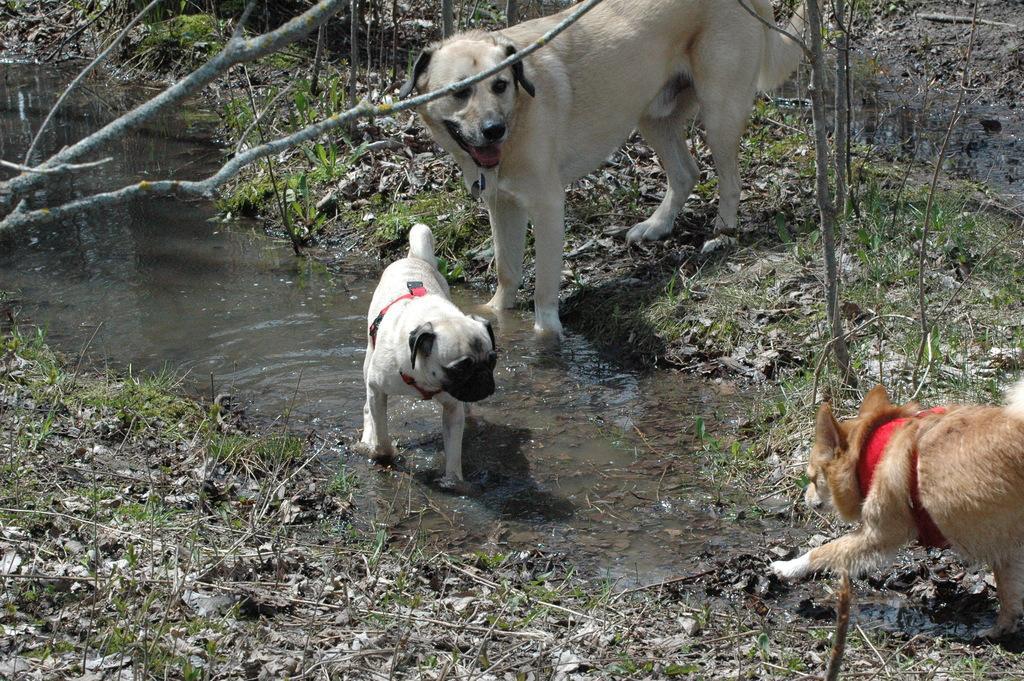Please provide a concise description of this image. In this image we can see dogs and there is water. In the background there are trees. At the bottom there is grass. 